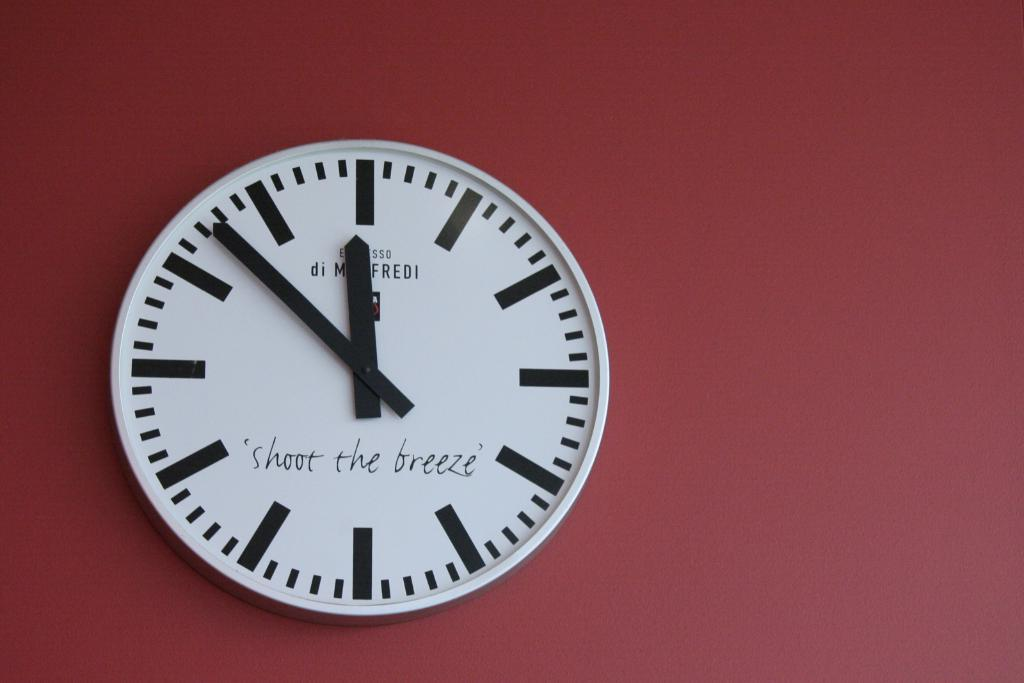<image>
Present a compact description of the photo's key features. The time is 11:53 on a clock that says "shoot the breeze." 